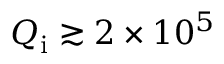Convert formula to latex. <formula><loc_0><loc_0><loc_500><loc_500>Q _ { i } \gtrsim 2 \times 1 0 ^ { 5 }</formula> 